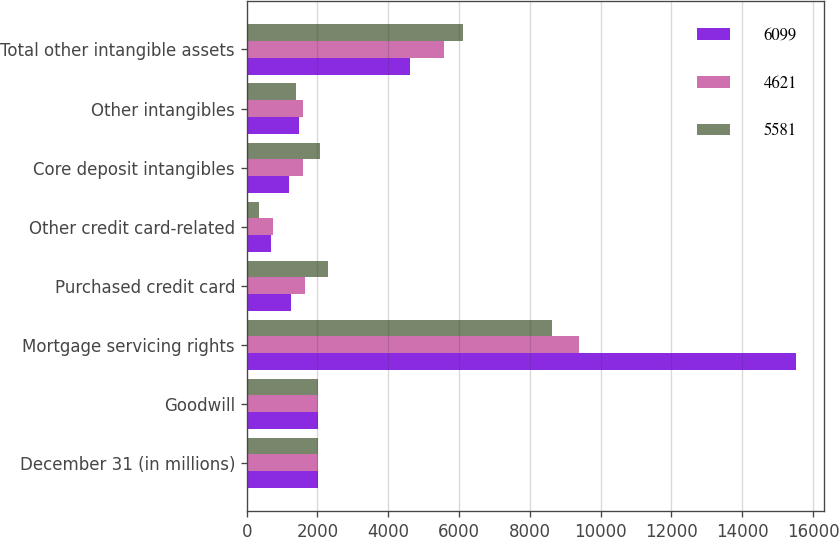<chart> <loc_0><loc_0><loc_500><loc_500><stacked_bar_chart><ecel><fcel>December 31 (in millions)<fcel>Goodwill<fcel>Mortgage servicing rights<fcel>Purchased credit card<fcel>Other credit card-related<fcel>Core deposit intangibles<fcel>Other intangibles<fcel>Total other intangible assets<nl><fcel>6099<fcel>2009<fcel>2007<fcel>15531<fcel>1246<fcel>691<fcel>1207<fcel>1477<fcel>4621<nl><fcel>4621<fcel>2008<fcel>2007<fcel>9403<fcel>1649<fcel>743<fcel>1597<fcel>1592<fcel>5581<nl><fcel>5581<fcel>2007<fcel>2007<fcel>8632<fcel>2303<fcel>346<fcel>2067<fcel>1383<fcel>6099<nl></chart> 